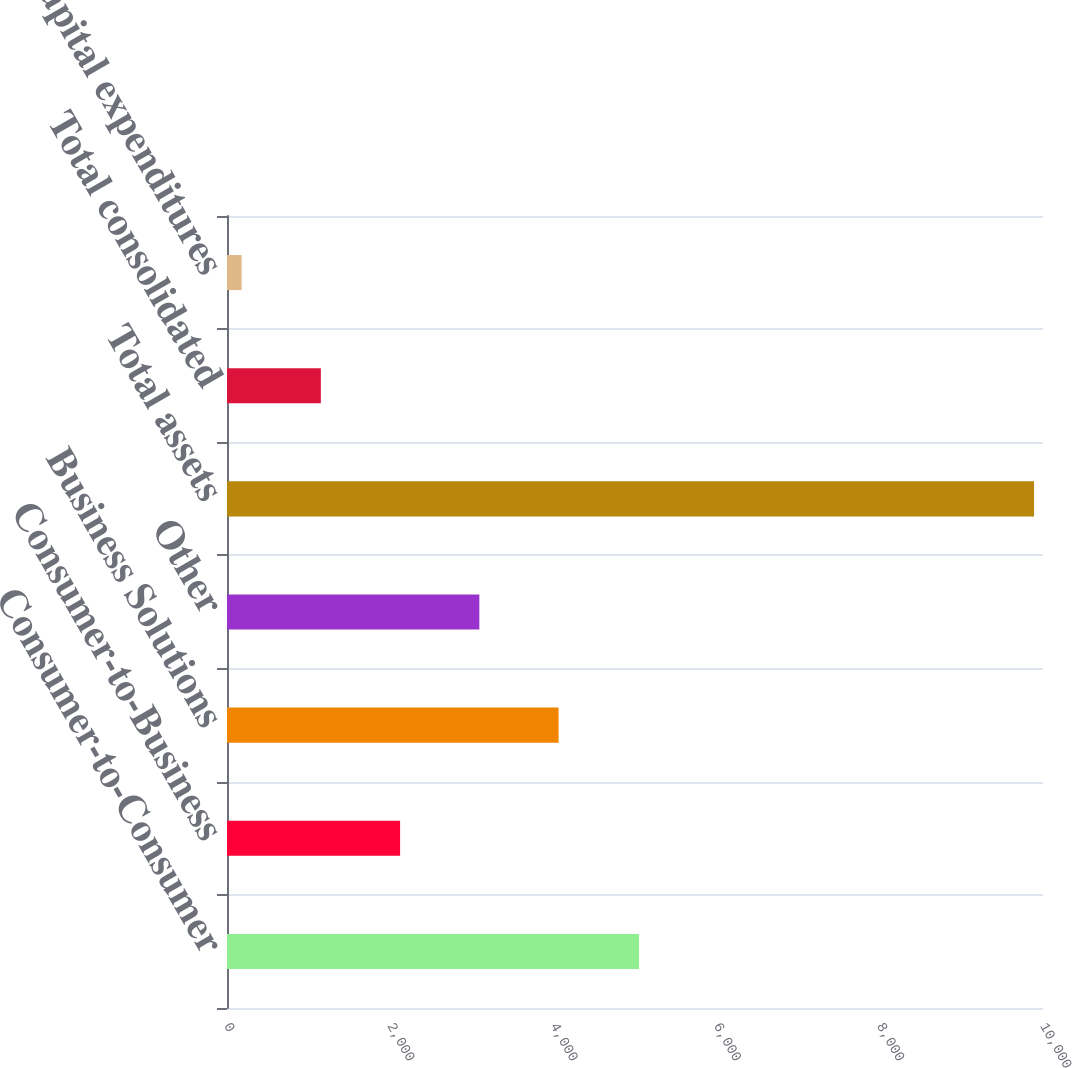Convert chart to OTSL. <chart><loc_0><loc_0><loc_500><loc_500><bar_chart><fcel>Consumer-to-Consumer<fcel>Consumer-to-Business<fcel>Business Solutions<fcel>Other<fcel>Total assets<fcel>Total consolidated<fcel>Total capital expenditures<nl><fcel>5049.7<fcel>2121.28<fcel>4063.56<fcel>3092.42<fcel>9890.4<fcel>1150.14<fcel>179<nl></chart> 